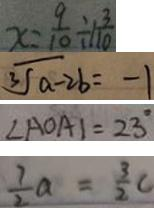<formula> <loc_0><loc_0><loc_500><loc_500>x = \frac { 9 } { 1 0 } \div 1 \frac { 3 } { 1 0 } 
 \sqrt [ 3 ] { a - 2 b } = - 1 
 \angle A O A \vert = 2 3 ^ { \circ } 
 \frac { 7 } { 2 } a = \frac { 3 } { 2 } C</formula> 